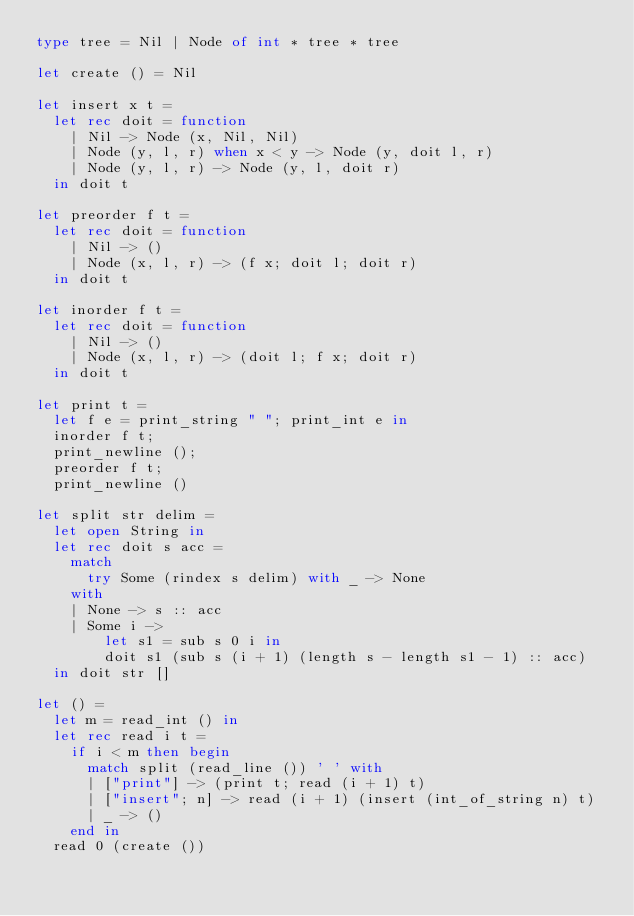<code> <loc_0><loc_0><loc_500><loc_500><_OCaml_>type tree = Nil | Node of int * tree * tree

let create () = Nil

let insert x t =
  let rec doit = function
    | Nil -> Node (x, Nil, Nil)
    | Node (y, l, r) when x < y -> Node (y, doit l, r)
    | Node (y, l, r) -> Node (y, l, doit r)
  in doit t

let preorder f t =
  let rec doit = function
    | Nil -> ()
    | Node (x, l, r) -> (f x; doit l; doit r)
  in doit t

let inorder f t =
  let rec doit = function
    | Nil -> ()
    | Node (x, l, r) -> (doit l; f x; doit r)
  in doit t

let print t =
  let f e = print_string " "; print_int e in
  inorder f t;
  print_newline ();
  preorder f t;
  print_newline ()

let split str delim =
  let open String in
  let rec doit s acc =
    match
      try Some (rindex s delim) with _ -> None
    with
    | None -> s :: acc
    | Some i ->
        let s1 = sub s 0 i in
        doit s1 (sub s (i + 1) (length s - length s1 - 1) :: acc)
  in doit str []

let () =
  let m = read_int () in
  let rec read i t =
    if i < m then begin
      match split (read_line ()) ' ' with
      | ["print"] -> (print t; read (i + 1) t)
      | ["insert"; n] -> read (i + 1) (insert (int_of_string n) t)
      | _ -> ()
    end in
  read 0 (create ())</code> 